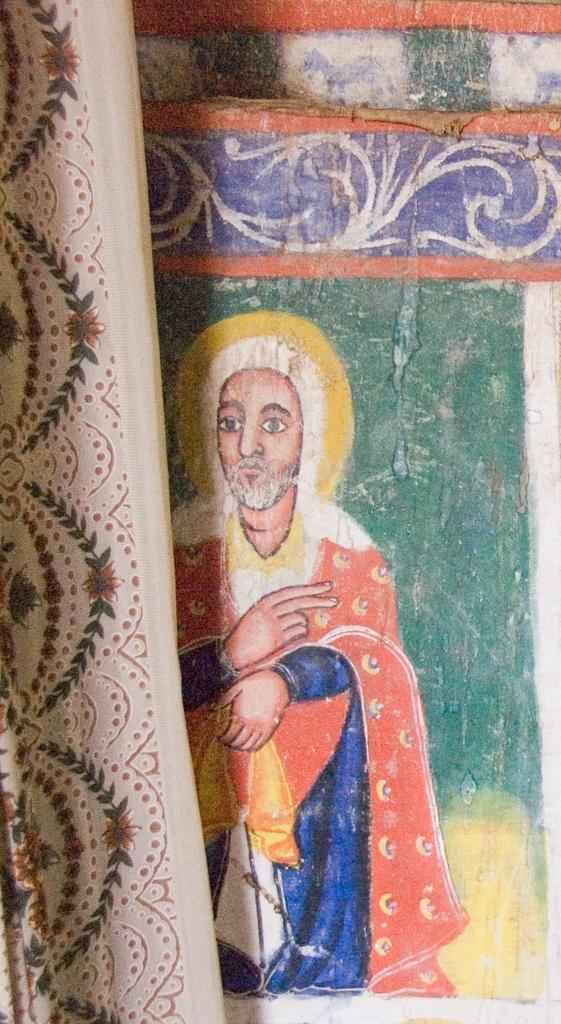Please provide a concise description of this image. In the image in the center, we can see one curtain, and wall. And we can see some painting on the wall, in which we can see one person. 